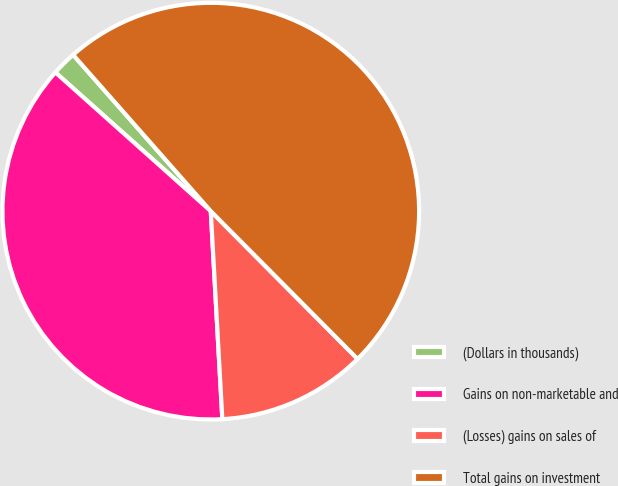<chart> <loc_0><loc_0><loc_500><loc_500><pie_chart><fcel>(Dollars in thousands)<fcel>Gains on non-marketable and<fcel>(Losses) gains on sales of<fcel>Total gains on investment<nl><fcel>1.91%<fcel>37.48%<fcel>11.56%<fcel>49.04%<nl></chart> 